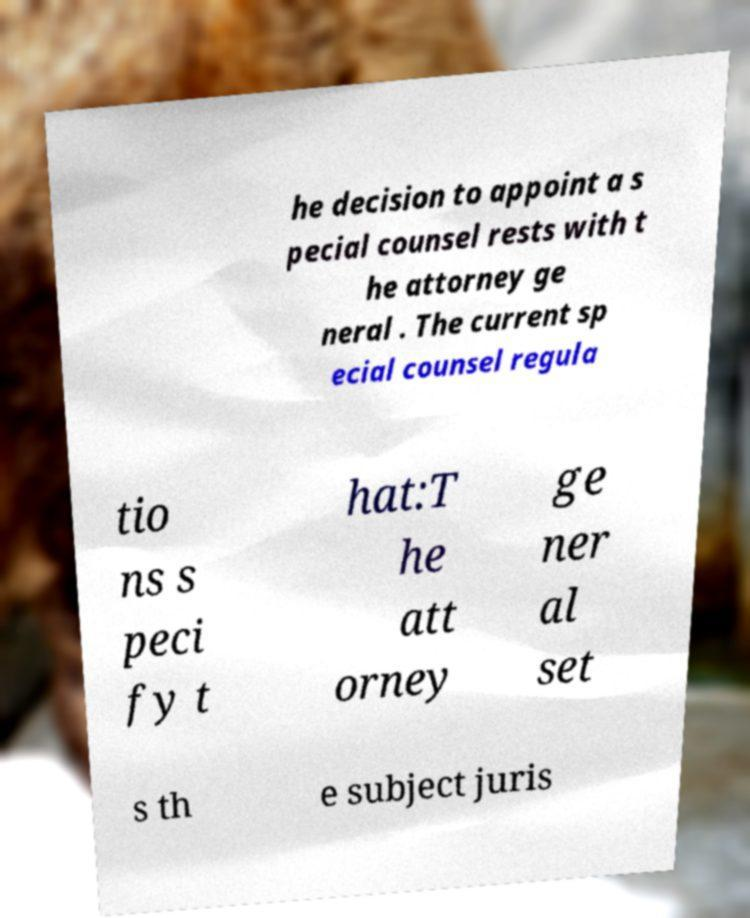Can you read and provide the text displayed in the image?This photo seems to have some interesting text. Can you extract and type it out for me? he decision to appoint a s pecial counsel rests with t he attorney ge neral . The current sp ecial counsel regula tio ns s peci fy t hat:T he att orney ge ner al set s th e subject juris 